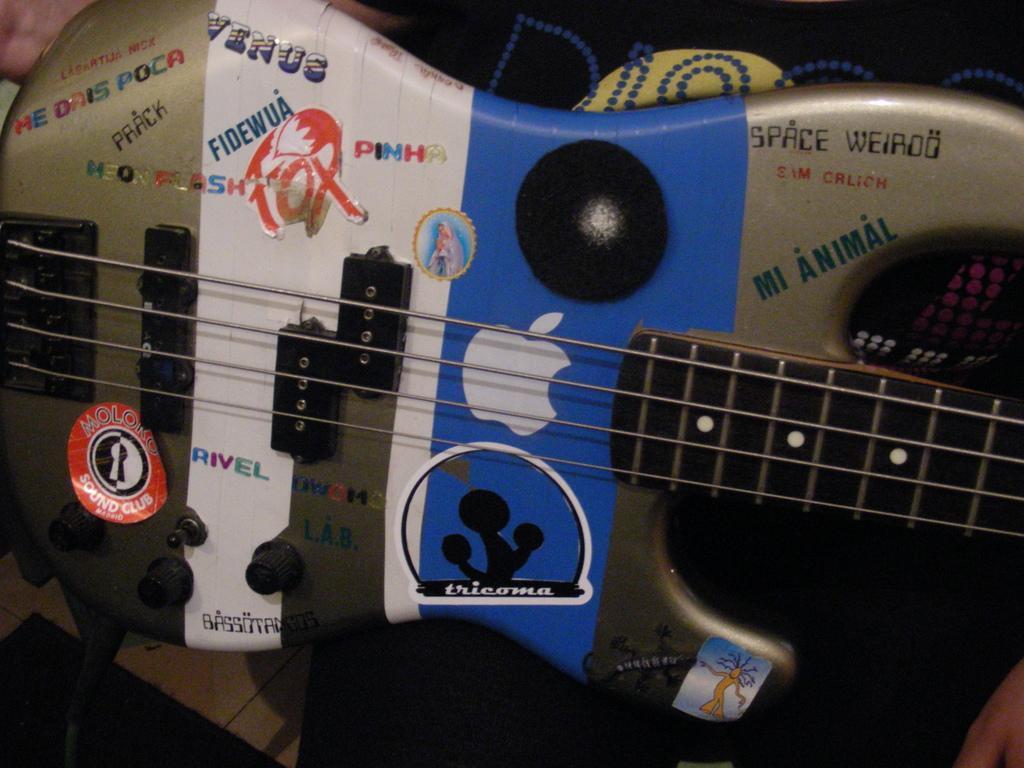How would you summarize this image in a sentence or two? In this image we can see a musical instrument. 